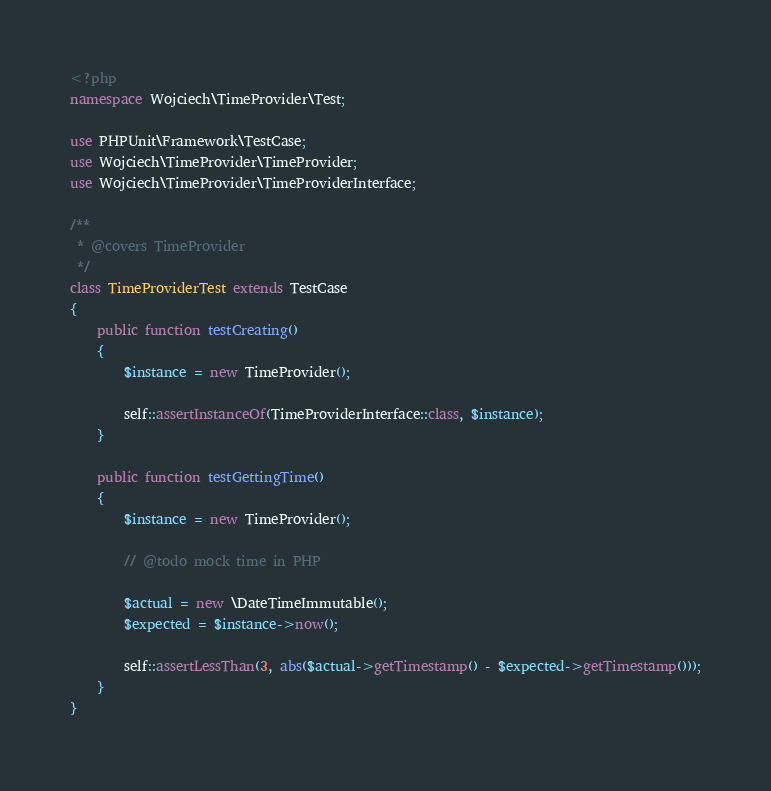Convert code to text. <code><loc_0><loc_0><loc_500><loc_500><_PHP_><?php
namespace Wojciech\TimeProvider\Test;

use PHPUnit\Framework\TestCase;
use Wojciech\TimeProvider\TimeProvider;
use Wojciech\TimeProvider\TimeProviderInterface;

/**
 * @covers TimeProvider
 */
class TimeProviderTest extends TestCase
{
    public function testCreating()
    {
        $instance = new TimeProvider();

        self::assertInstanceOf(TimeProviderInterface::class, $instance);
    }

    public function testGettingTime()
    {
        $instance = new TimeProvider();

        // @todo mock time in PHP

        $actual = new \DateTimeImmutable();
        $expected = $instance->now();

        self::assertLessThan(3, abs($actual->getTimestamp() - $expected->getTimestamp()));
    }
}
</code> 